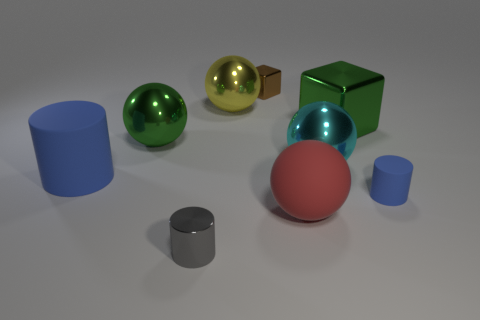Is there anything else that has the same size as the green metallic sphere?
Ensure brevity in your answer.  Yes. Is there a sphere that has the same size as the cyan object?
Make the answer very short. Yes. There is a large matte object to the right of the big blue matte cylinder; is its color the same as the tiny thing behind the tiny rubber cylinder?
Keep it short and to the point. No. How many shiny objects are green cubes or big cyan spheres?
Give a very brief answer. 2. There is a green object that is to the left of the small shiny object in front of the small matte object; what number of cylinders are left of it?
Your answer should be compact. 1. What size is the cyan sphere that is made of the same material as the large yellow ball?
Keep it short and to the point. Large. How many large rubber spheres have the same color as the large rubber cylinder?
Offer a very short reply. 0. Do the blue rubber cylinder that is on the right side of the gray metallic cylinder and the big blue cylinder have the same size?
Your response must be concise. No. There is a object that is left of the gray cylinder and behind the large matte cylinder; what is its color?
Your answer should be very brief. Green. What number of objects are yellow balls or metal balls that are on the right side of the gray cylinder?
Make the answer very short. 2. 